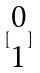Convert formula to latex. <formula><loc_0><loc_0><loc_500><loc_500>[ \begin{matrix} 0 \\ 1 \end{matrix} ]</formula> 